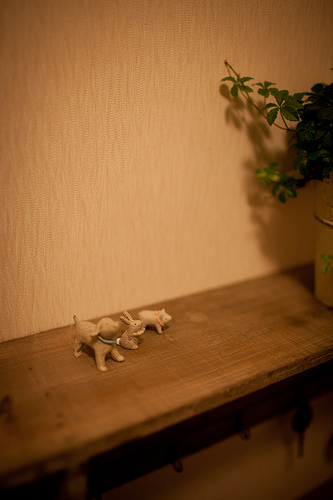<image>
Is the toy next to the plant? Yes. The toy is positioned adjacent to the plant, located nearby in the same general area. 